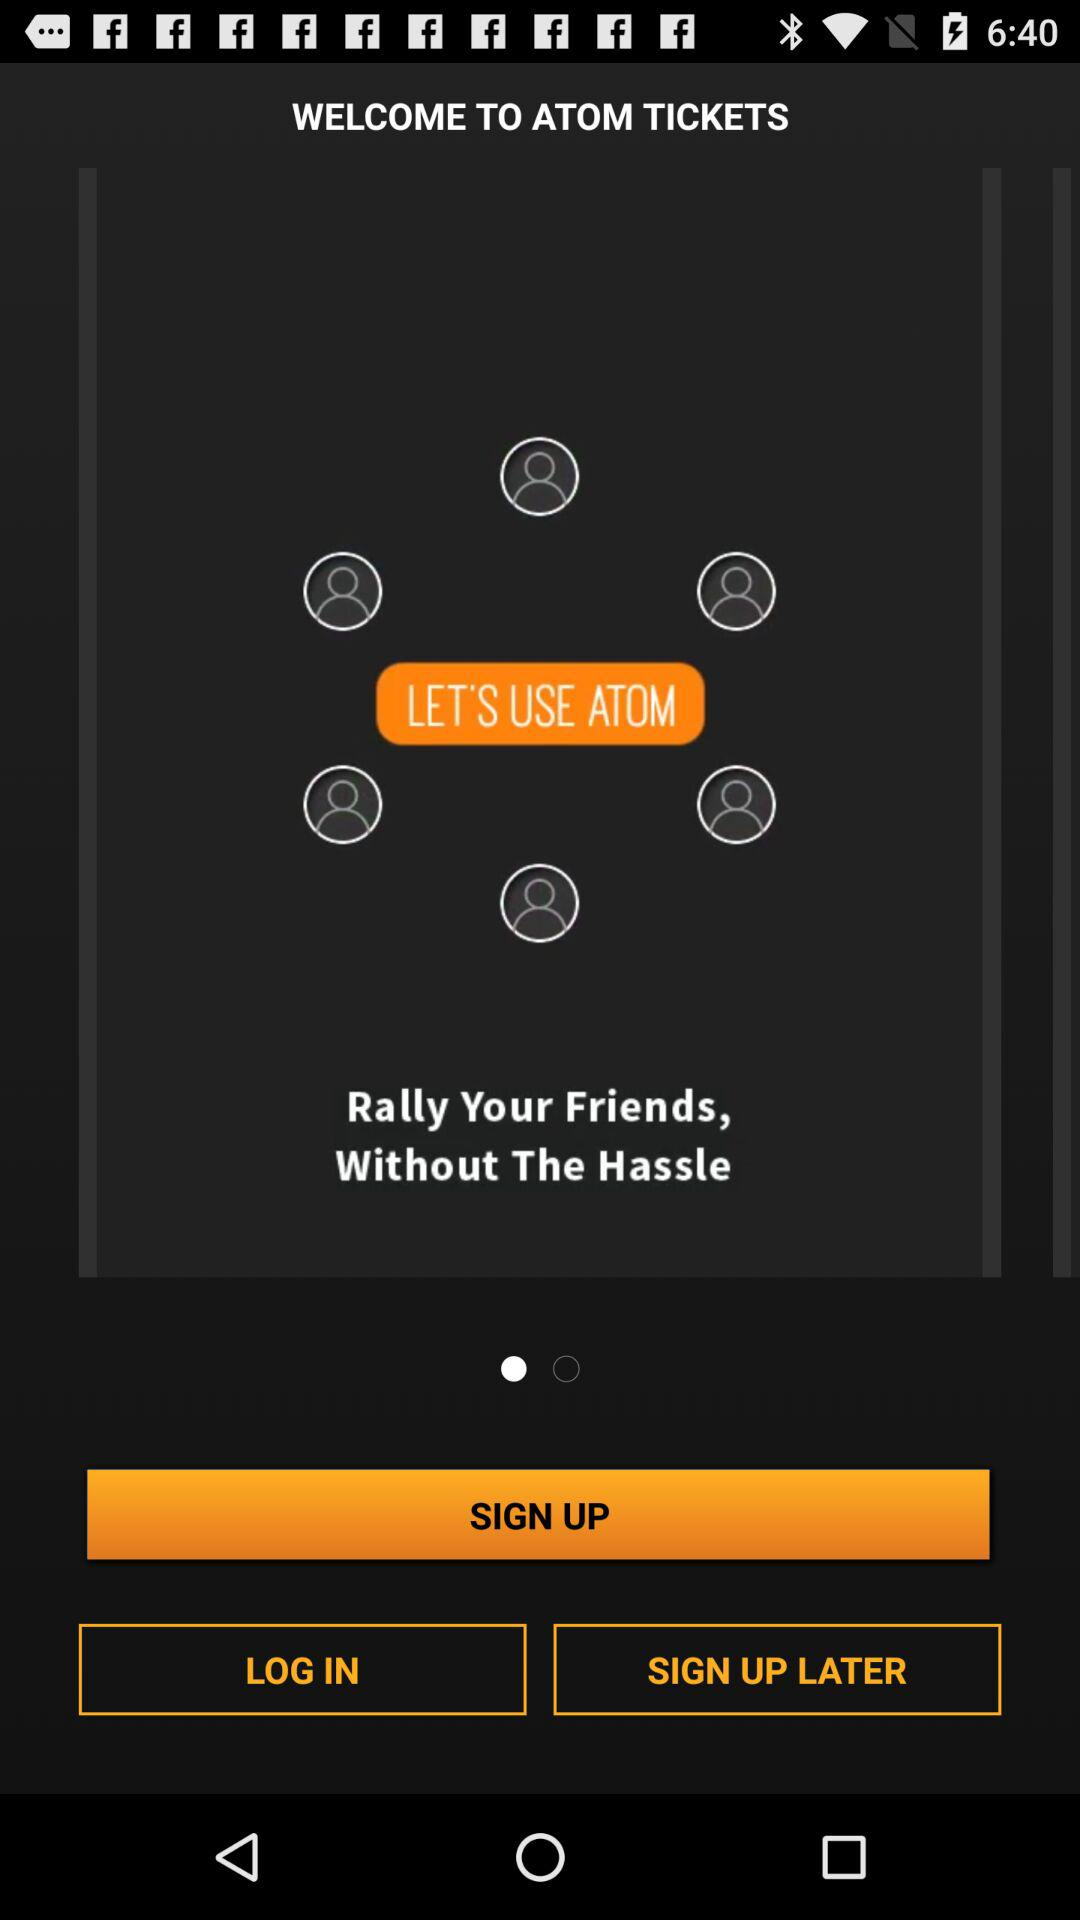What is the name of the application? The name of the application is "ATOM". 